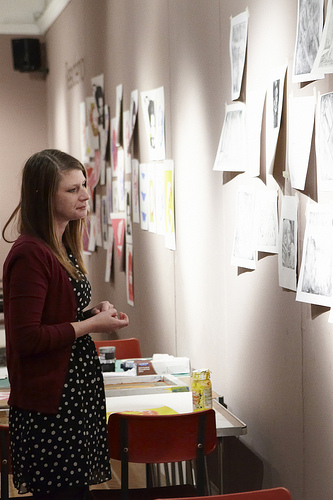<image>
Is the chair behind the woman? No. The chair is not behind the woman. From this viewpoint, the chair appears to be positioned elsewhere in the scene. 